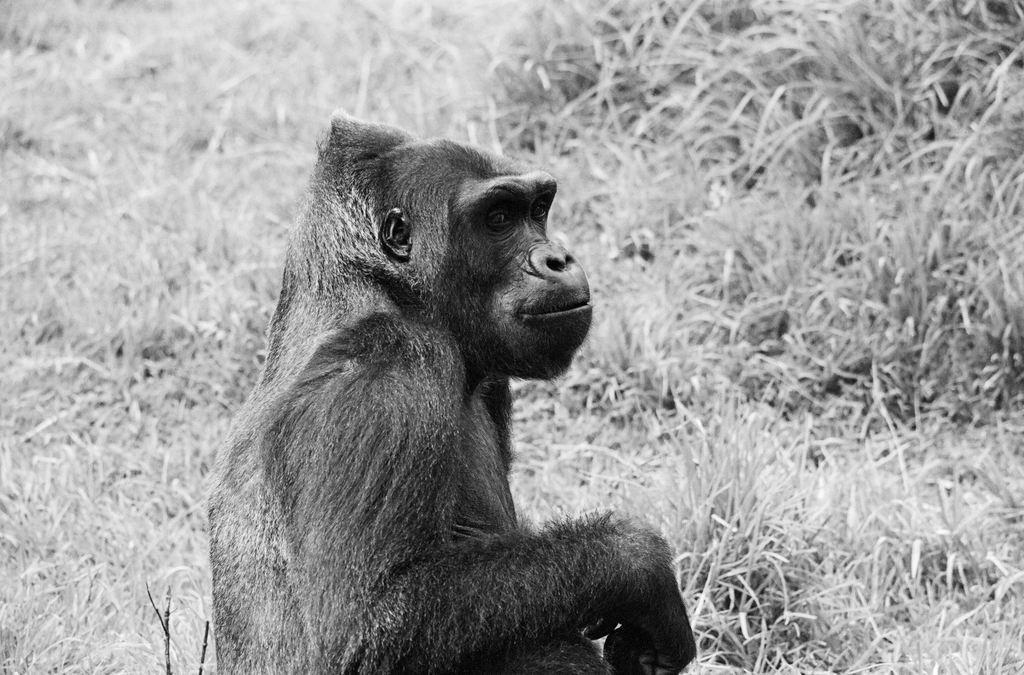Please provide a concise description of this image. This is the black and white image where we can see the chimpanzee. In the background, we can see the grass. 